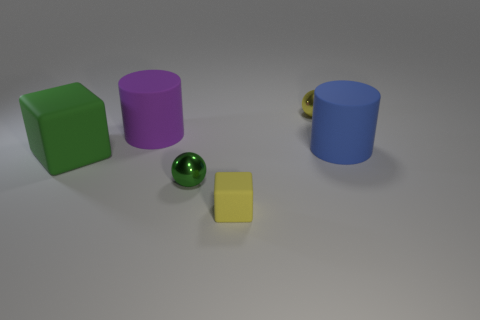Is there any other thing that is the same shape as the small green object? Yes, there is a yellow object that shares the same cube shape as the small green object. Both have six faces, twelve edges, and eight vertices, classifying them as geometrically identical cubes. 